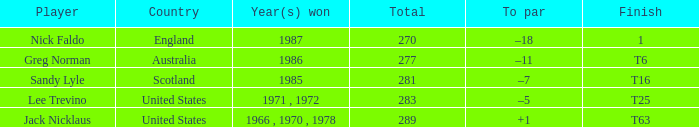I'm looking to parse the entire table for insights. Could you assist me with that? {'header': ['Player', 'Country', 'Year(s) won', 'Total', 'To par', 'Finish'], 'rows': [['Nick Faldo', 'England', '1987', '270', '–18', '1'], ['Greg Norman', 'Australia', '1986', '277', '–11', 'T6'], ['Sandy Lyle', 'Scotland', '1985', '281', '–7', 'T16'], ['Lee Trevino', 'United States', '1971 , 1972', '283', '–5', 'T25'], ['Jack Nicklaus', 'United States', '1966 , 1970 , 1978', '289', '+1', 'T63']]} What player has 289 as the total? Jack Nicklaus. 